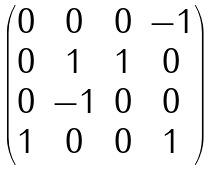<formula> <loc_0><loc_0><loc_500><loc_500>\begin{pmatrix} 0 & 0 & 0 & - 1 \\ 0 & 1 & 1 & 0 \\ 0 & - 1 & 0 & 0 \\ 1 & 0 & 0 & 1 \end{pmatrix}</formula> 